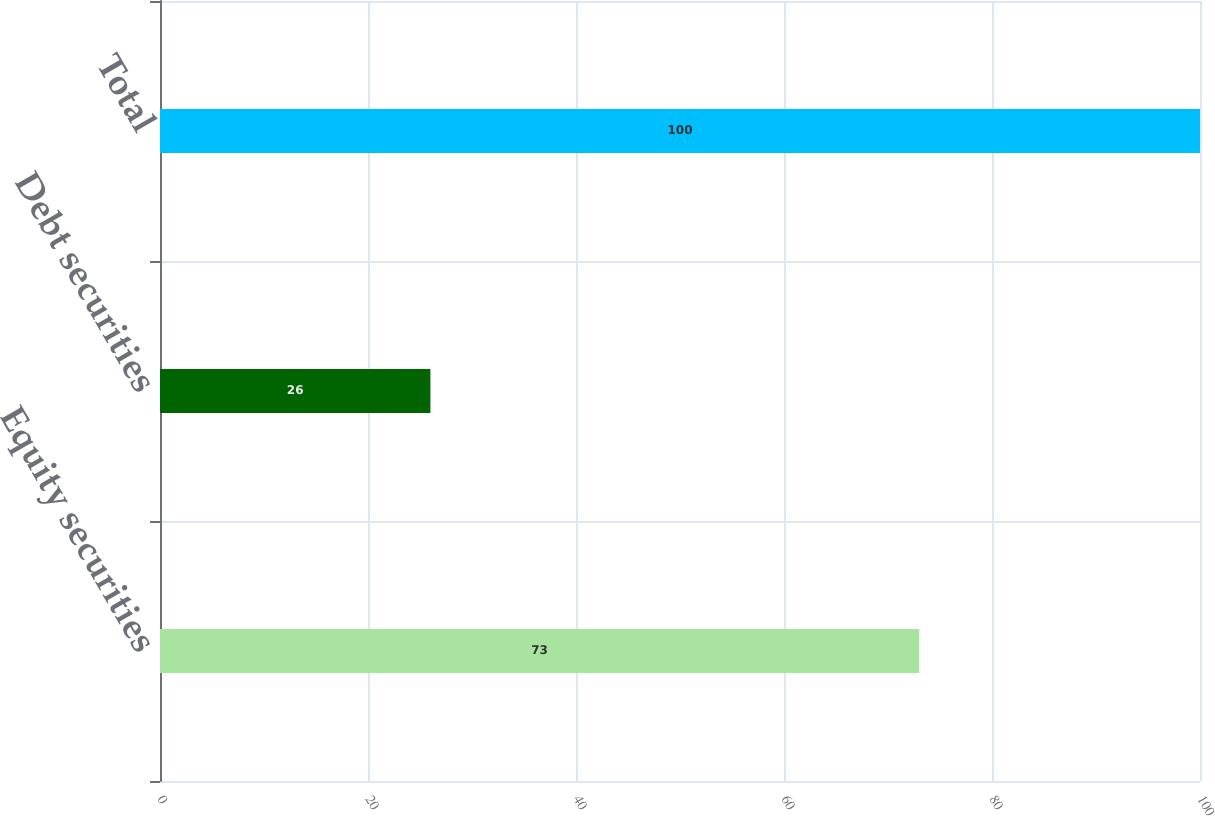<chart> <loc_0><loc_0><loc_500><loc_500><bar_chart><fcel>Equity securities<fcel>Debt securities<fcel>Total<nl><fcel>73<fcel>26<fcel>100<nl></chart> 